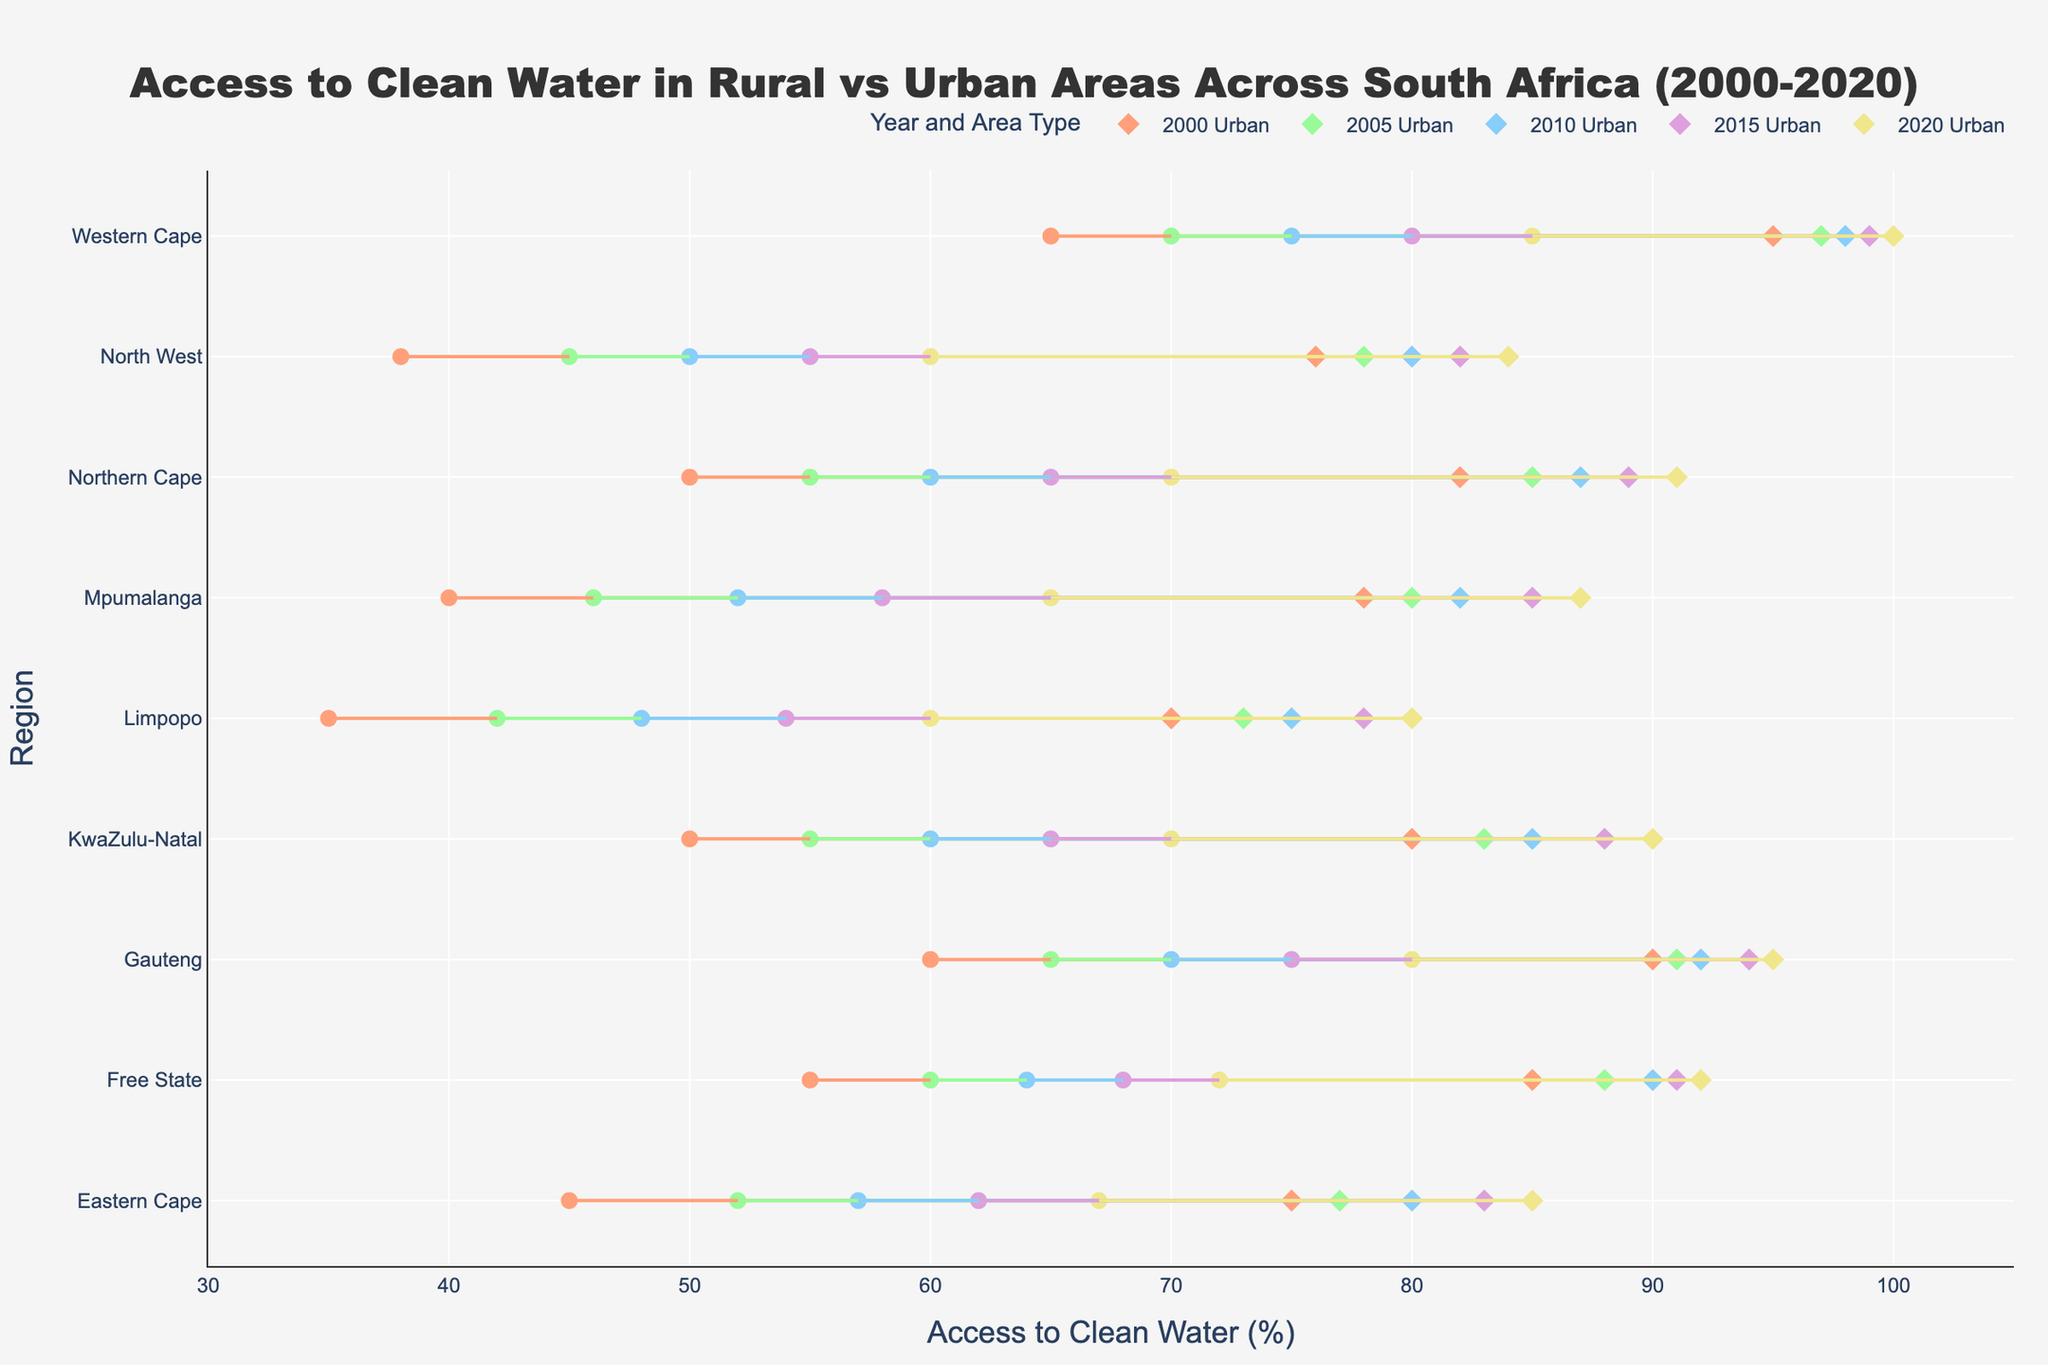What's the title of the figure? The title is usually displayed at the top of the figure. In this case, it is given in the code as "Access to Clean Water in Rural vs Urban Areas Across South Africa (2000-2020)".
Answer: Access to Clean Water in Rural vs Urban Areas Across South Africa (2000-2020) Which year had the highest overall access to clean water in urban areas in the Western Cape? By looking for the highest urban access value for the Western Cape across all years, we see it is 100% in 2020.
Answer: 2020 How many regions are represented in the figure? The regions are the labels on the y-axis. In the data columns, nine distinct regions are represented.
Answer: 9 What is the range of access to clean water percentages shown on the x-axis? The x-axis ranges are usually explicitly defined. In this case, the code indicates the x-axis range is from 30% to 105%.
Answer: 30%-105% In 2015, what was the difference in access to clean water between rural and urban areas in Limpopo? Look at the data points for Limpopo in 2015. Access in rural areas was 54%, and urban areas were 78%. The difference is 78% - 54% = 24%.
Answer: 24% Which region showed the least progress in access to clean water from 2000 to 2020 in rural areas? Compare the growth in access to clean water from 2000 to 2020 in rural areas across all regions. Limpopo had access grow from 35% to 60%, which is a 25% increase, the least among the regions.
Answer: Limpopo In 2010, which region had the smallest gap between rural and urban access to clean water? Calculate the difference between rural and urban access for each region in 2010 and find the smallest one. Northern Cape had 60% rural and 87% urban, a gap of 27%.
Answer: Northern Cape How does the gap between rural and urban access to clean water change over time for the Free State? Observe the gaps for the Free State for multiple years: 2000 (85-55=30), 2005 (88-60=28), 2010 (90-64=26), 2015 (91-68=23), 2020 (92-72=20). The gap gradually decreases over time.
Answer: Decreases Which year shows the greatest disparity between rural and urban access in KwaZulu-Natal? Compare the gaps in the given years for KwaZulu-Natal: 2000 (30), 2005 (28), 2010 (25), 2015 (23), 2020 (20). The greatest disparity is in 2000 with a gap of 30%.
Answer: 2000 